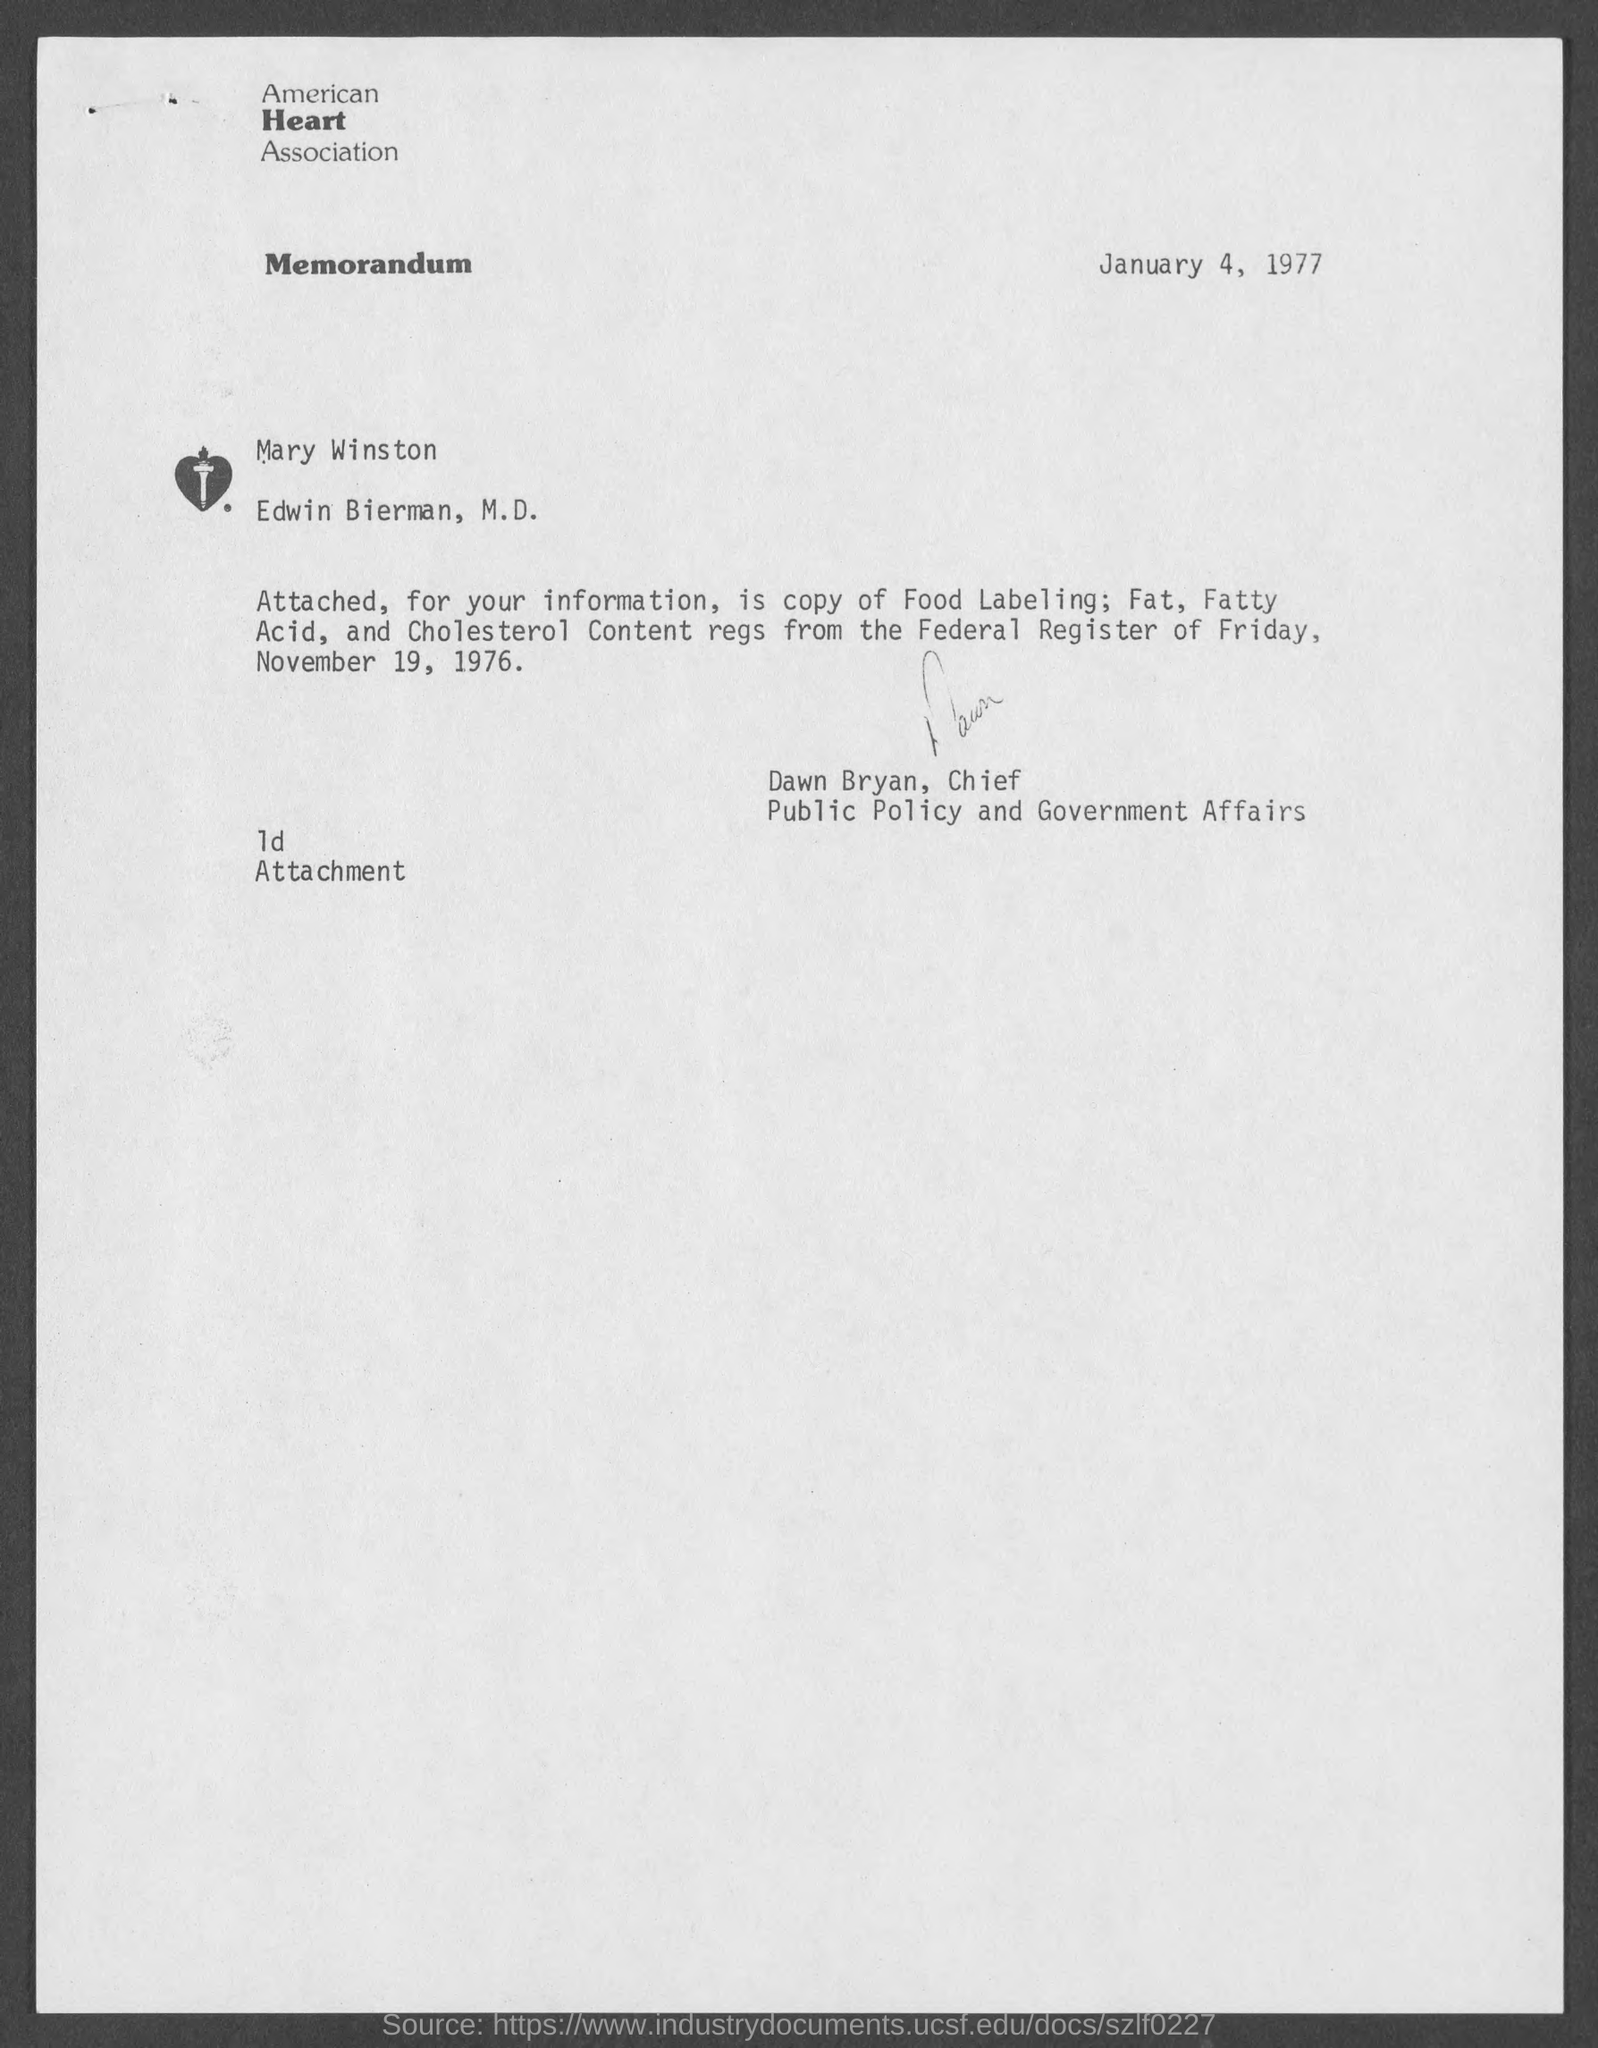List a handful of essential elements in this visual. The memorandum is dated January 4, 1977. The American Heart Association is the name of the Heart Association. 